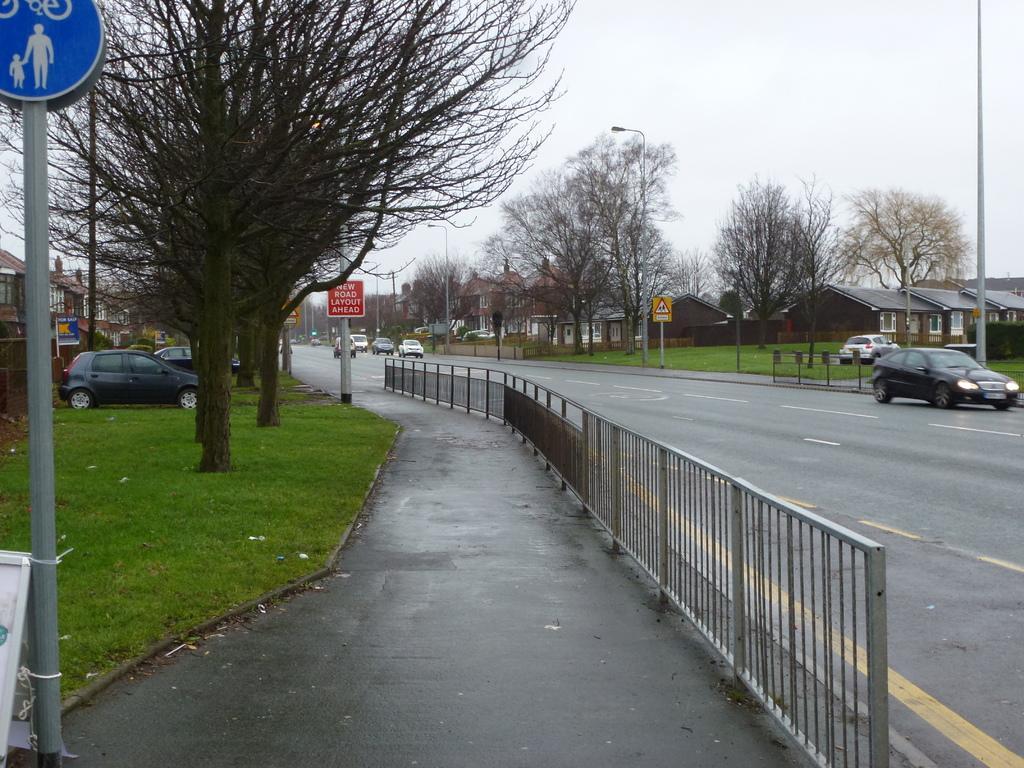Please provide a concise description of this image. In this image we can see a fence, grass, poles, boards, houses, trees, and vehicles. In the background there is sky. 